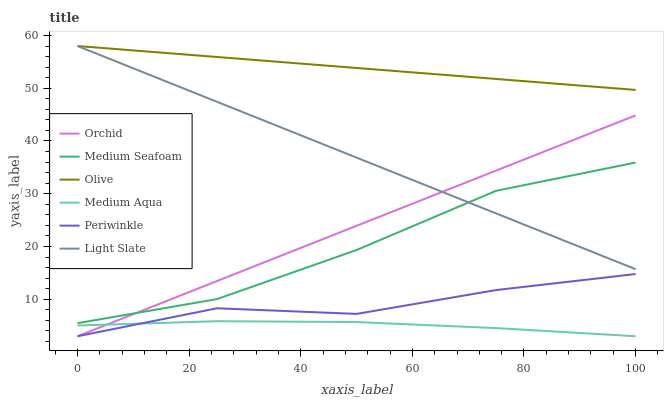Does Periwinkle have the minimum area under the curve?
Answer yes or no. No. Does Periwinkle have the maximum area under the curve?
Answer yes or no. No. Is Olive the smoothest?
Answer yes or no. No. Is Olive the roughest?
Answer yes or no. No. Does Olive have the lowest value?
Answer yes or no. No. Does Periwinkle have the highest value?
Answer yes or no. No. Is Periwinkle less than Olive?
Answer yes or no. Yes. Is Light Slate greater than Periwinkle?
Answer yes or no. Yes. Does Periwinkle intersect Olive?
Answer yes or no. No. 